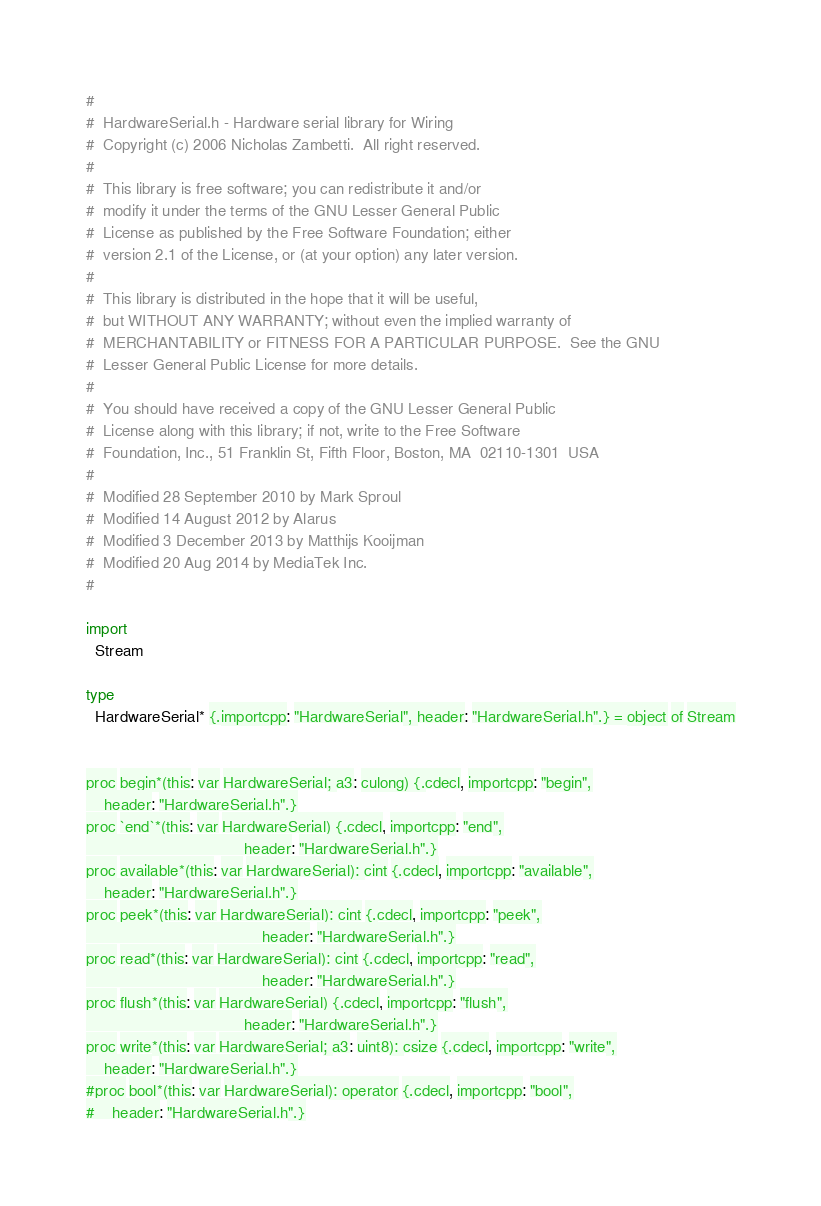<code> <loc_0><loc_0><loc_500><loc_500><_Nim_>#
#  HardwareSerial.h - Hardware serial library for Wiring
#  Copyright (c) 2006 Nicholas Zambetti.  All right reserved.
#
#  This library is free software; you can redistribute it and/or
#  modify it under the terms of the GNU Lesser General Public
#  License as published by the Free Software Foundation; either
#  version 2.1 of the License, or (at your option) any later version.
#
#  This library is distributed in the hope that it will be useful,
#  but WITHOUT ANY WARRANTY; without even the implied warranty of
#  MERCHANTABILITY or FITNESS FOR A PARTICULAR PURPOSE.  See the GNU
#  Lesser General Public License for more details.
#
#  You should have received a copy of the GNU Lesser General Public
#  License along with this library; if not, write to the Free Software
#  Foundation, Inc., 51 Franklin St, Fifth Floor, Boston, MA  02110-1301  USA
#
#  Modified 28 September 2010 by Mark Sproul
#  Modified 14 August 2012 by Alarus
#  Modified 3 December 2013 by Matthijs Kooijman
#  Modified 20 Aug 2014 by MediaTek Inc.
#

import
  Stream

type
  HardwareSerial* {.importcpp: "HardwareSerial", header: "HardwareSerial.h".} = object of Stream
  

proc begin*(this: var HardwareSerial; a3: culong) {.cdecl, importcpp: "begin",
    header: "HardwareSerial.h".}
proc `end`*(this: var HardwareSerial) {.cdecl, importcpp: "end",
                                    header: "HardwareSerial.h".}
proc available*(this: var HardwareSerial): cint {.cdecl, importcpp: "available",
    header: "HardwareSerial.h".}
proc peek*(this: var HardwareSerial): cint {.cdecl, importcpp: "peek",
                                        header: "HardwareSerial.h".}
proc read*(this: var HardwareSerial): cint {.cdecl, importcpp: "read",
                                        header: "HardwareSerial.h".}
proc flush*(this: var HardwareSerial) {.cdecl, importcpp: "flush",
                                    header: "HardwareSerial.h".}
proc write*(this: var HardwareSerial; a3: uint8): csize {.cdecl, importcpp: "write",
    header: "HardwareSerial.h".}
#proc bool*(this: var HardwareSerial): operator {.cdecl, importcpp: "bool",
#    header: "HardwareSerial.h".}
</code> 